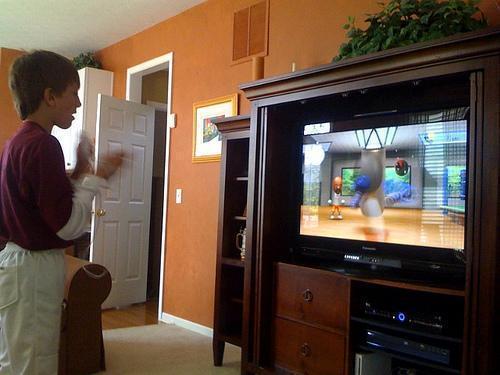What is the person engaged in?
Make your selection and explain in format: 'Answer: answer
Rationale: rationale.'
Options: Gaming, debate, discussion, sports. Answer: gaming.
Rationale: The person is gaming. 